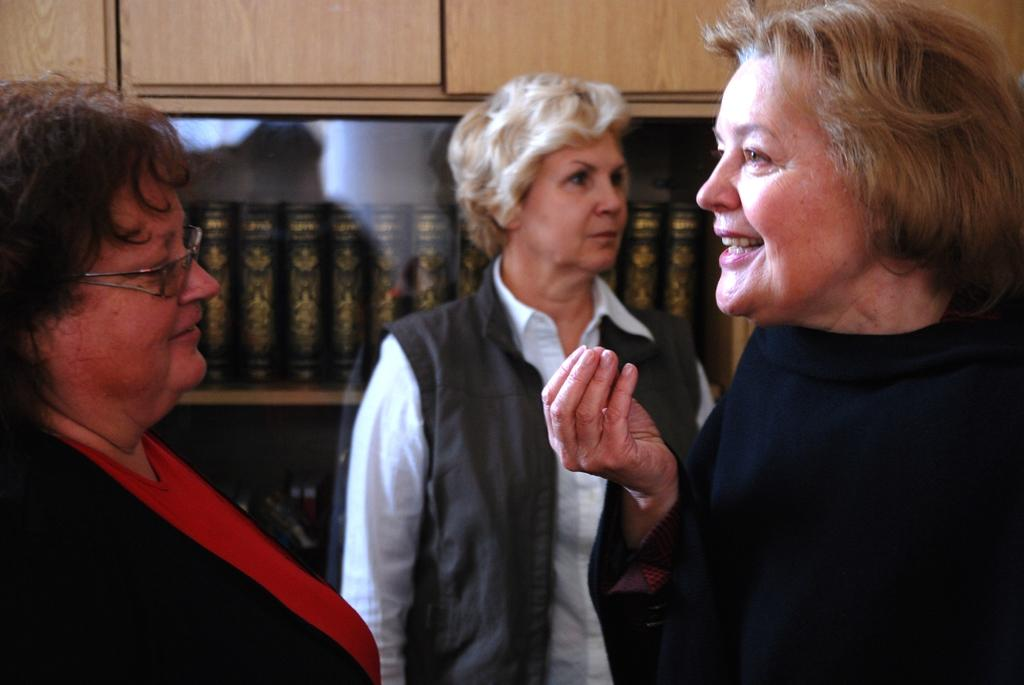How many women are present in the image? There are three women standing in the image. Can you describe any specific features of one of the women? One of the women is wearing glasses. What can be seen in the background of the image? There is a cupboard in the background of the image. What is inside the cupboard? There are books inside the cupboard. What type of ocean scene can be seen in the background of the image? There is no ocean scene present in the image; it features three women and a cupboard with books. What historical event is depicted in the image? There is no historical event depicted in the image; it is a simple scene of three women and a cupboard with books. 